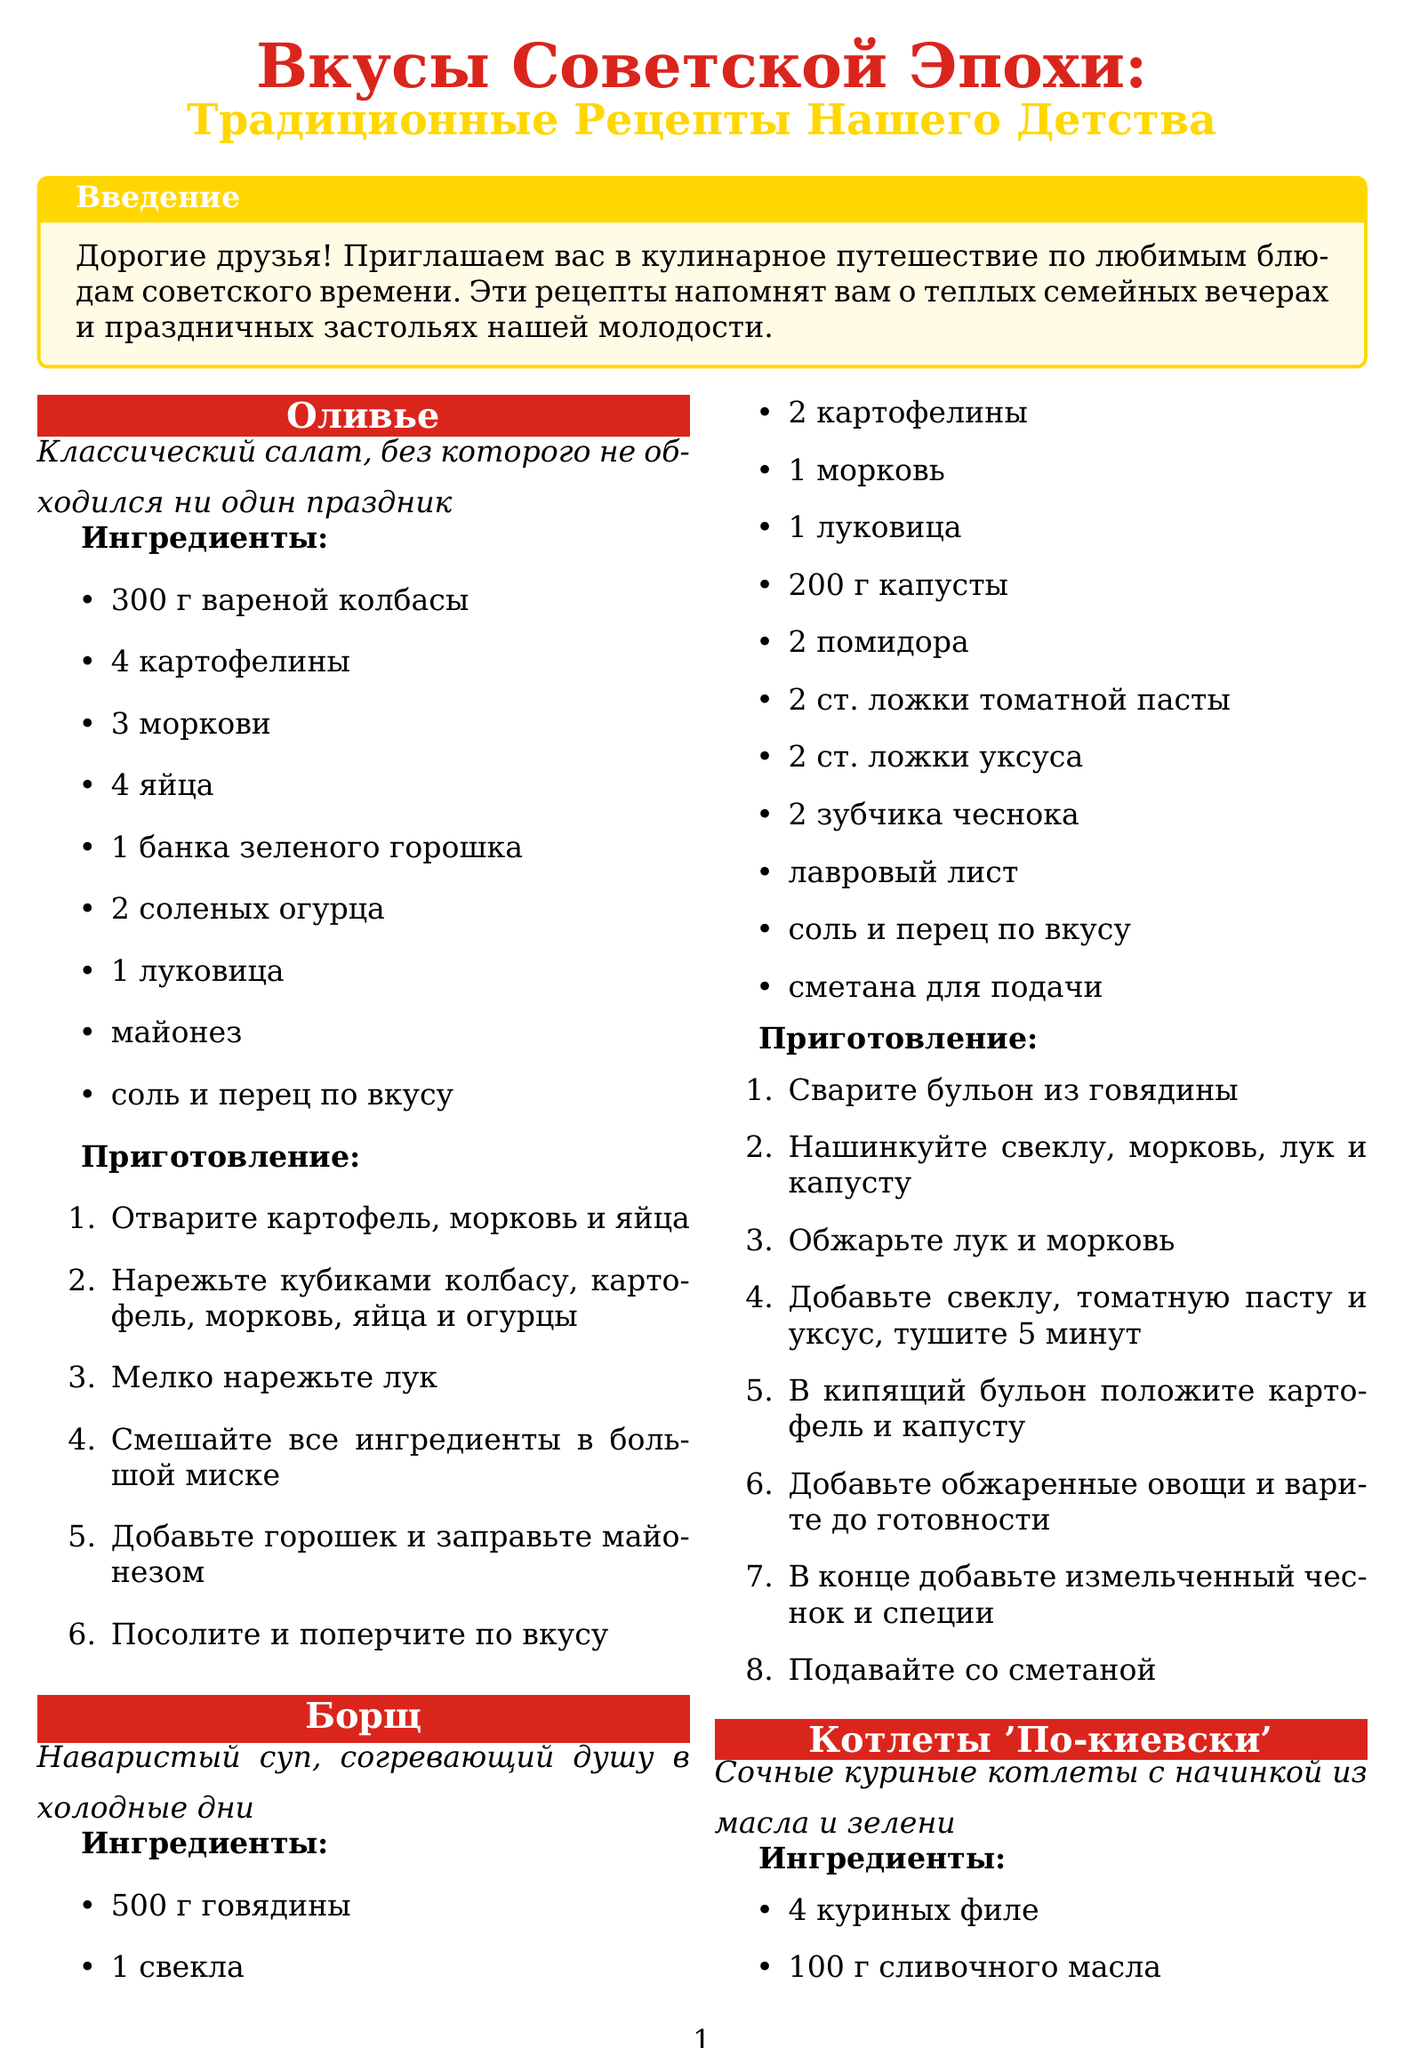what is the title of the brochure? The title of the brochure is presented at the beginning and is "Вкусы Советской Эпохи: Традиционные Рецепты Нашего Детства".
Answer: Вкусы Советской Эпохи: Традиционные Рецепты Нашего Детства how many recipes are included in the brochure? The number of recipes can be counted from the list in the document. There are four recipes mentioned.
Answer: 4 what is the first recipe listed? The first recipe name is mentioned in the document as "Оливье".
Answer: Оливье what is the main ingredient for Борщ? The main ingredient is indicated at the beginning of the Борщ recipe section, highlighting its key components. It mentions "говядина".
Answer: говядина how should Котлеты 'По-киевски' be cooked after frying? The instructions specify that after frying, they should be "доведите до готовности в духовке при 180°C 15-20 минут".
Answer: при 180°C 15-20 минут what is the decorative theme of the brochure? The design elements section describes the visual theme, including its focus on nostalgic and Soviet-style decorations.
Answer: советских плакатах what is the conclusion emphasizing? The conclusion summarizes the essence of the recipes presented in the brochure, highlighting their significance.
Answer: наша история и традиции 